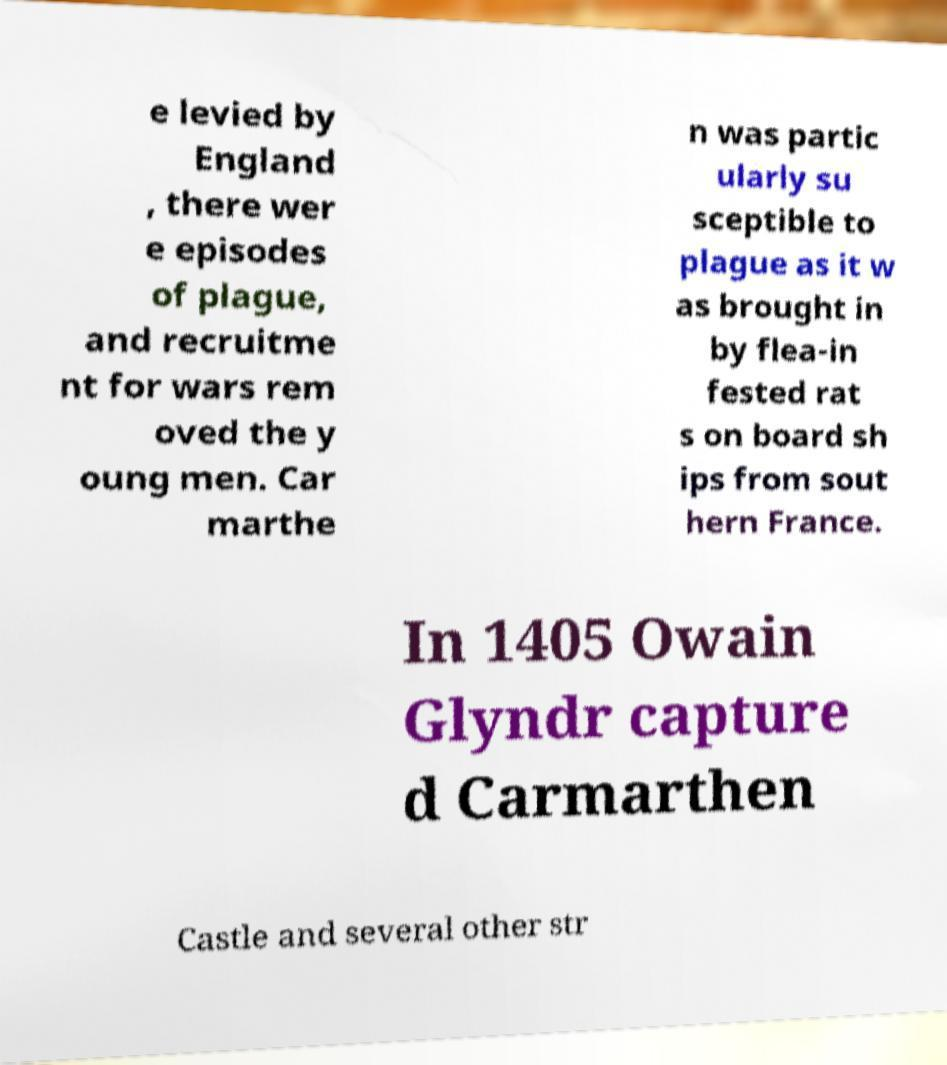Please read and relay the text visible in this image. What does it say? e levied by England , there wer e episodes of plague, and recruitme nt for wars rem oved the y oung men. Car marthe n was partic ularly su sceptible to plague as it w as brought in by flea-in fested rat s on board sh ips from sout hern France. In 1405 Owain Glyndr capture d Carmarthen Castle and several other str 